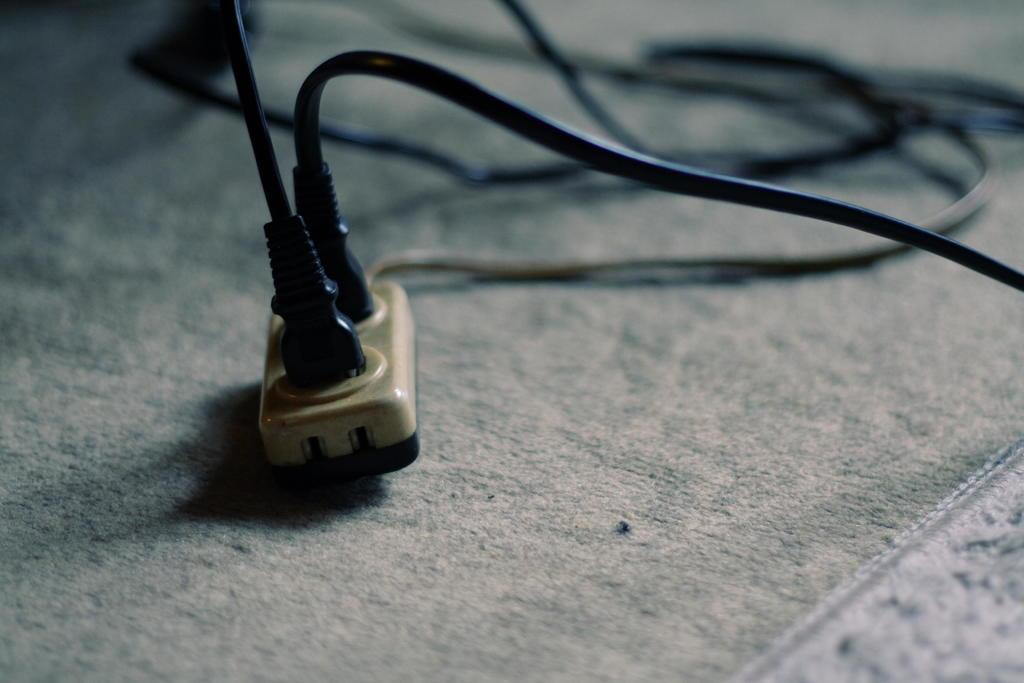What can be seen in the image related to electrical connections? There is a plug board in the image. What is the color of the plug board? The plug board is brown in color. How many wires are visible in the image? There are two black wires in the image. What type of peace symbol can be seen on the plug board in the image? There is no peace symbol present on the plug board in the image. 